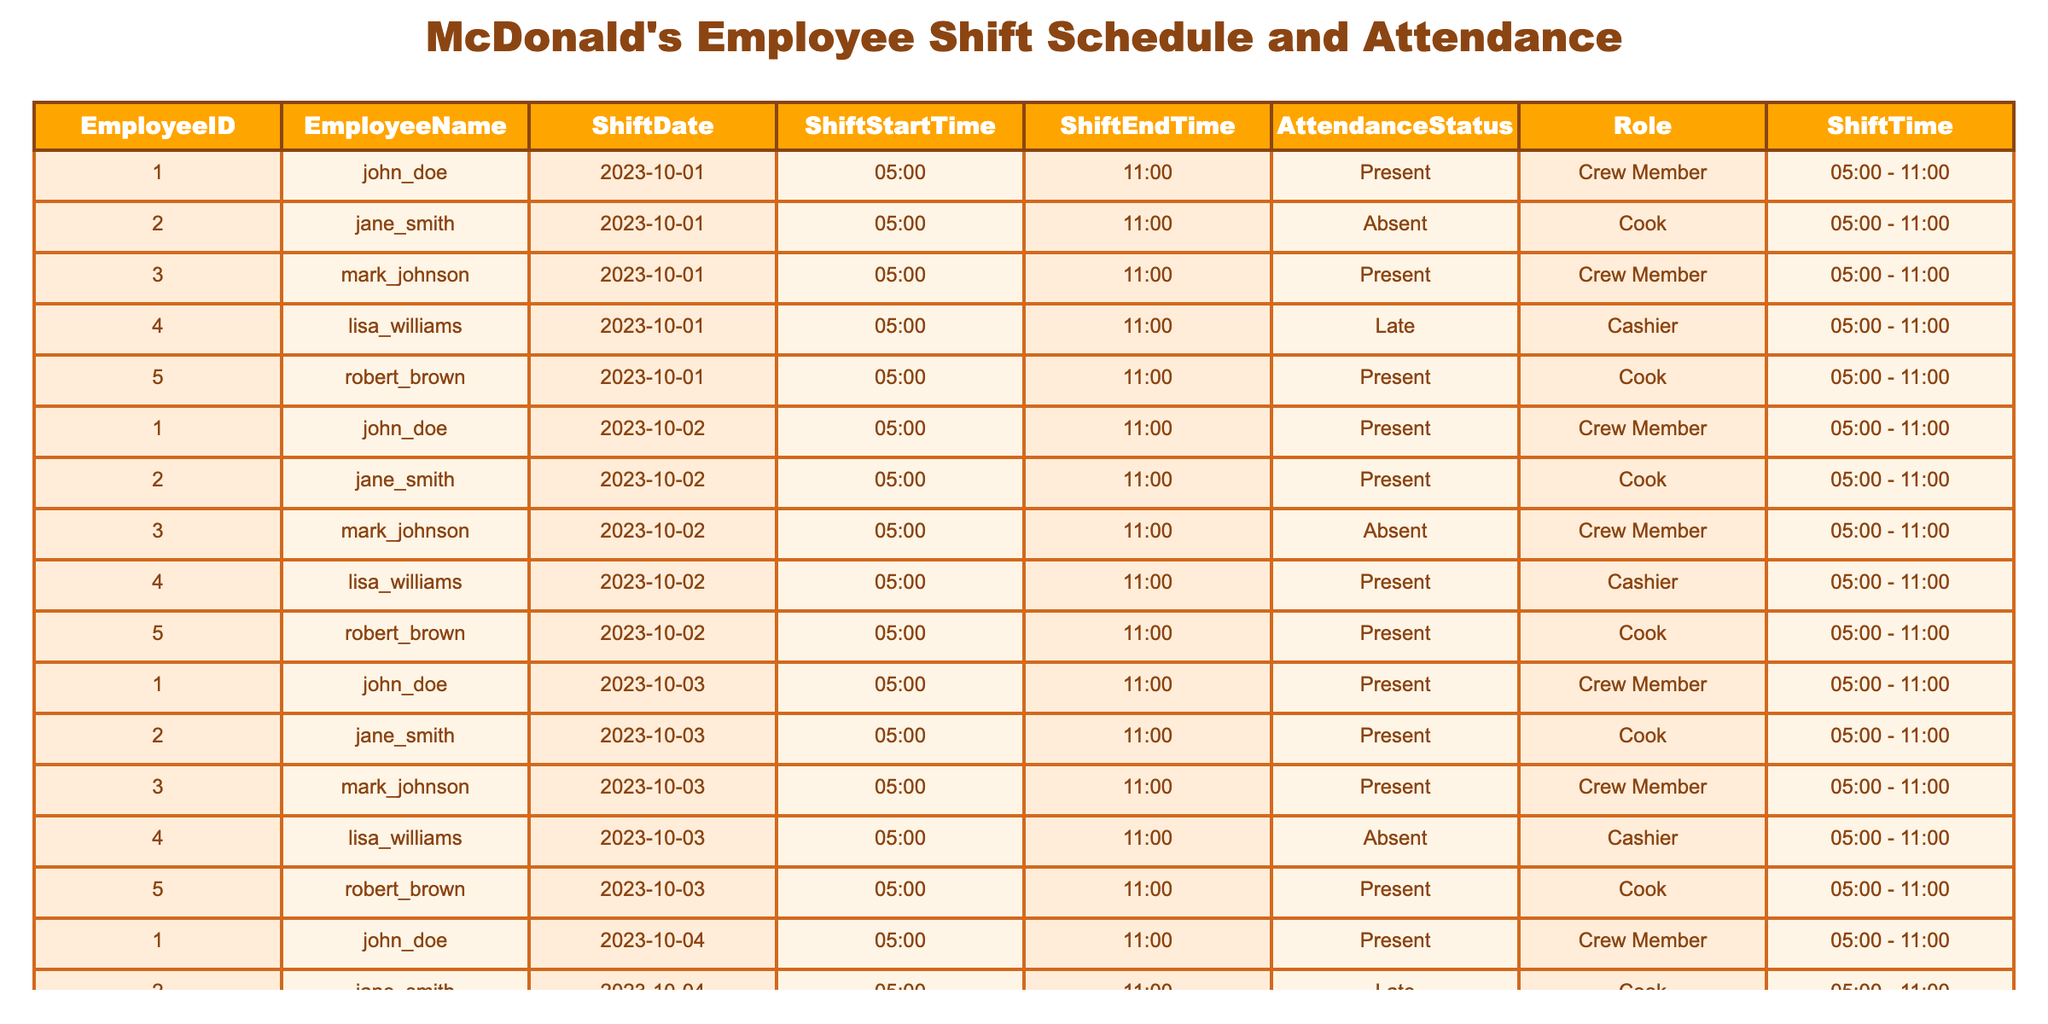What is the attendance status of Lisa Williams on October 3, 2023? Referring to the table, look at the row with ShiftDate as October 3, 2023 and find Lisa Williams. Her AttendanceStatus is listed as Absent.
Answer: Absent How many days did John Doe attend work during the recorded dates? John Doe is present on October 1, 2, 3, and 4 but absent on October 5. Therefore, he attended work for 4 days.
Answer: 4 Did any cook have an unexcused absence during the given dates? Examining the records for cooks, Jane Smith is absent on October 1, indicating an unexcused absence. So, yes, there was an unexcused absence.
Answer: Yes What is the total number of shifts for Robert Brown in the table? Robert Brown has a shift recorded for each date from October 1 to October 5, making a total of 5 shifts.
Answer: 5 On which date did Lisa Williams arrive late for work? Checking Lisa Williams' records, she arrived late on October 1. This detail can be found under the AttendanceStatus column for the corresponding date.
Answer: October 1 How many total shifts did Crew Members have during the recorded dates? Reviewing the table, both John Doe and Mark Johnson are Crew Members. John worked 4 days and Mark worked 3 days, so the total for Crew Members is 4 + 3 = 7 shifts.
Answer: 7 What was the attendance status of Jane Smith on October 4, 2023? Referring to the records, Jane Smith was marked as Late on October 4. This information can be found in the row corresponding to that date.
Answer: Late Who worked the earliest shift on October 5, 2023, and what was their role? All employees in the provided information started their shifts at 05:00. Hence, the earliest shift on October 5 was for John Doe, Mark Johnson, and Robert Brown, and they all had the role of Crew Member, Cook, and Cook respectively.
Answer: John Doe, Crew Member What percentage of shifts did Robert Brown attend out of the total shifts scheduled for him? He attended 5 shifts out of 5 scheduled, which calculates to (5/5) * 100 = 100%.
Answer: 100% 